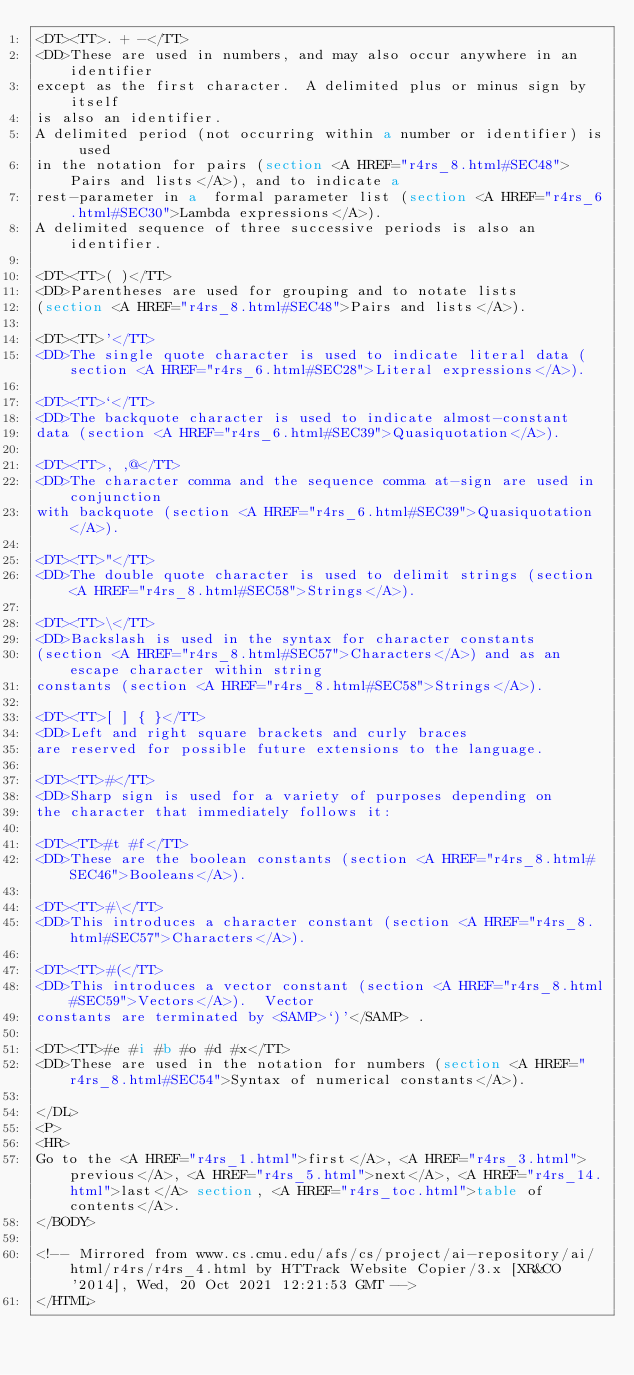<code> <loc_0><loc_0><loc_500><loc_500><_HTML_><DT><TT>. + -</TT>
<DD>These are used in numbers, and may also occur anywhere in an identifier
except as the first character.  A delimited plus or minus sign by itself
is also an identifier.
A delimited period (not occurring within a number or identifier) is used
in the notation for pairs (section <A HREF="r4rs_8.html#SEC48">Pairs and lists</A>), and to indicate a
rest-parameter in a  formal parameter list (section <A HREF="r4rs_6.html#SEC30">Lambda expressions</A>).
A delimited sequence of three successive periods is also an identifier.

<DT><TT>( )</TT>
<DD>Parentheses are used for grouping and to notate lists
(section <A HREF="r4rs_8.html#SEC48">Pairs and lists</A>).

<DT><TT>'</TT>
<DD>The single quote character is used to indicate literal data (section <A HREF="r4rs_6.html#SEC28">Literal expressions</A>).

<DT><TT>`</TT>
<DD>The backquote character is used to indicate almost-constant
data (section <A HREF="r4rs_6.html#SEC39">Quasiquotation</A>).

<DT><TT>, ,@</TT>
<DD>The character comma and the sequence comma at-sign are used in conjunction
with backquote (section <A HREF="r4rs_6.html#SEC39">Quasiquotation</A>).

<DT><TT>"</TT>
<DD>The double quote character is used to delimit strings (section <A HREF="r4rs_8.html#SEC58">Strings</A>).

<DT><TT>\</TT>
<DD>Backslash is used in the syntax for character constants
(section <A HREF="r4rs_8.html#SEC57">Characters</A>) and as an escape character within string
constants (section <A HREF="r4rs_8.html#SEC58">Strings</A>).

<DT><TT>[ ] { }</TT>
<DD>Left and right square brackets and curly braces
are reserved for possible future extensions to the language.

<DT><TT>#</TT>
<DD>Sharp sign is used for a variety of purposes depending on
the character that immediately follows it:

<DT><TT>#t #f</TT>
<DD>These are the boolean constants (section <A HREF="r4rs_8.html#SEC46">Booleans</A>).

<DT><TT>#\</TT>
<DD>This introduces a character constant (section <A HREF="r4rs_8.html#SEC57">Characters</A>).

<DT><TT>#(</TT>
<DD>This introduces a vector constant (section <A HREF="r4rs_8.html#SEC59">Vectors</A>).  Vector
constants are terminated by <SAMP>`)'</SAMP> .

<DT><TT>#e #i #b #o #d #x</TT>
<DD>These are used in the notation for numbers (section <A HREF="r4rs_8.html#SEC54">Syntax of numerical constants</A>).

</DL>
<P>
<HR>
Go to the <A HREF="r4rs_1.html">first</A>, <A HREF="r4rs_3.html">previous</A>, <A HREF="r4rs_5.html">next</A>, <A HREF="r4rs_14.html">last</A> section, <A HREF="r4rs_toc.html">table of contents</A>.
</BODY>

<!-- Mirrored from www.cs.cmu.edu/afs/cs/project/ai-repository/ai/html/r4rs/r4rs_4.html by HTTrack Website Copier/3.x [XR&CO'2014], Wed, 20 Oct 2021 12:21:53 GMT -->
</HTML>
</code> 